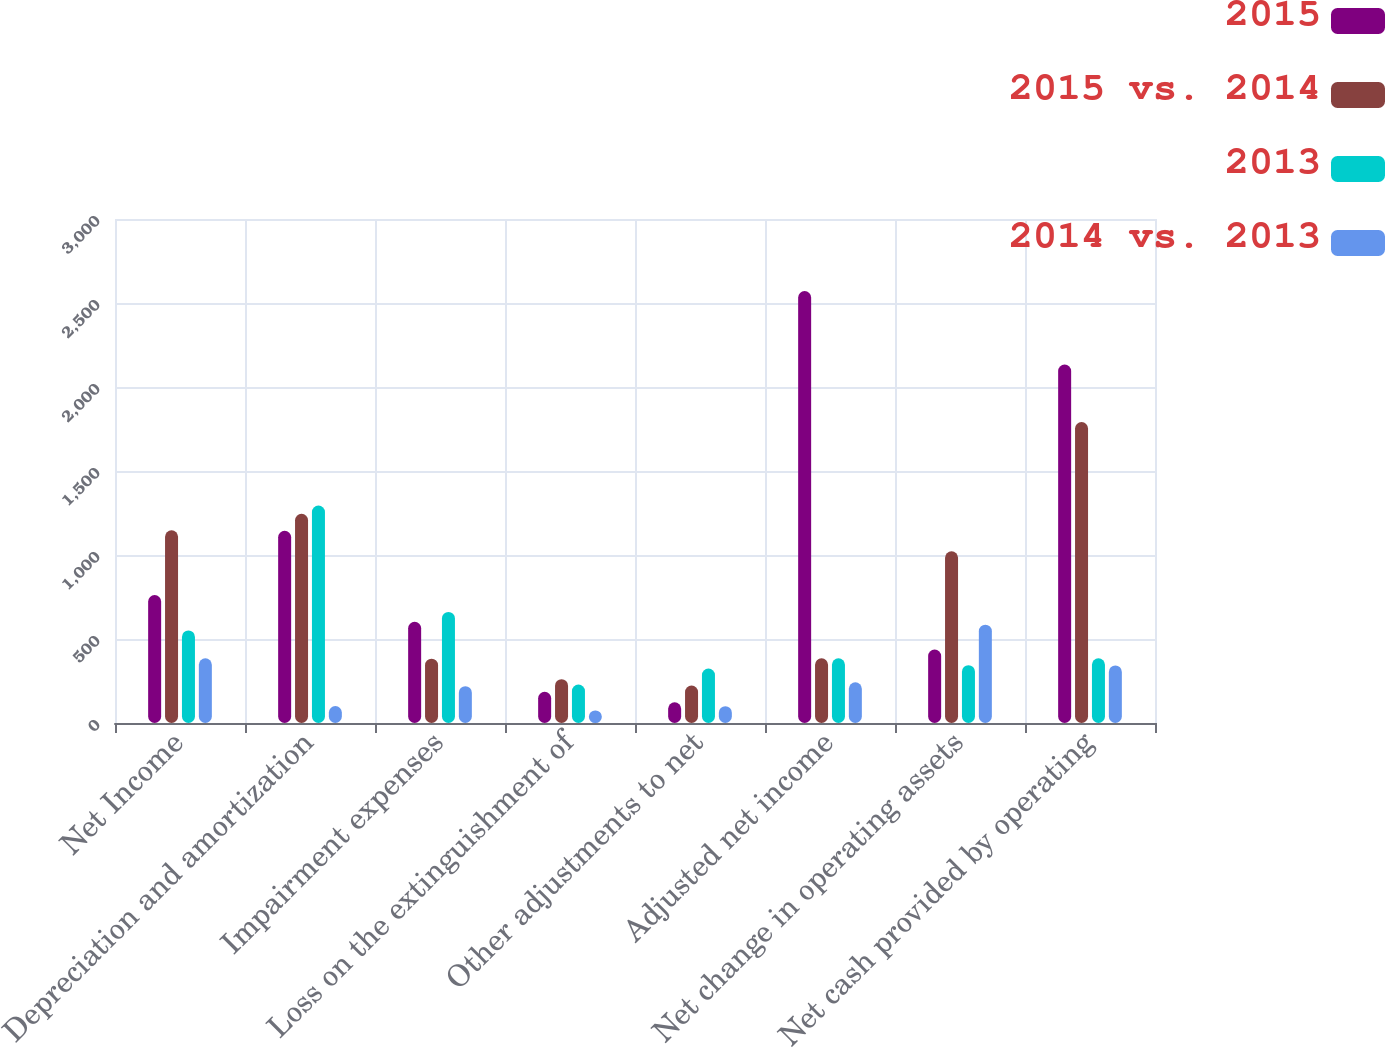Convert chart to OTSL. <chart><loc_0><loc_0><loc_500><loc_500><stacked_bar_chart><ecel><fcel>Net Income<fcel>Depreciation and amortization<fcel>Impairment expenses<fcel>Loss on the extinguishment of<fcel>Other adjustments to net<fcel>Adjusted net income<fcel>Net change in operating assets<fcel>Net cash provided by operating<nl><fcel>2015<fcel>762<fcel>1144<fcel>602<fcel>186<fcel>123<fcel>2571<fcel>437<fcel>2134<nl><fcel>2015 vs. 2014<fcel>1147<fcel>1245<fcel>383<fcel>261<fcel>223<fcel>385<fcel>1022<fcel>1791<nl><fcel>2013<fcel>551<fcel>1294<fcel>661<fcel>229<fcel>324<fcel>385<fcel>344<fcel>385<nl><fcel>2014 vs. 2013<fcel>385<fcel>101<fcel>219<fcel>75<fcel>100<fcel>242<fcel>585<fcel>343<nl></chart> 